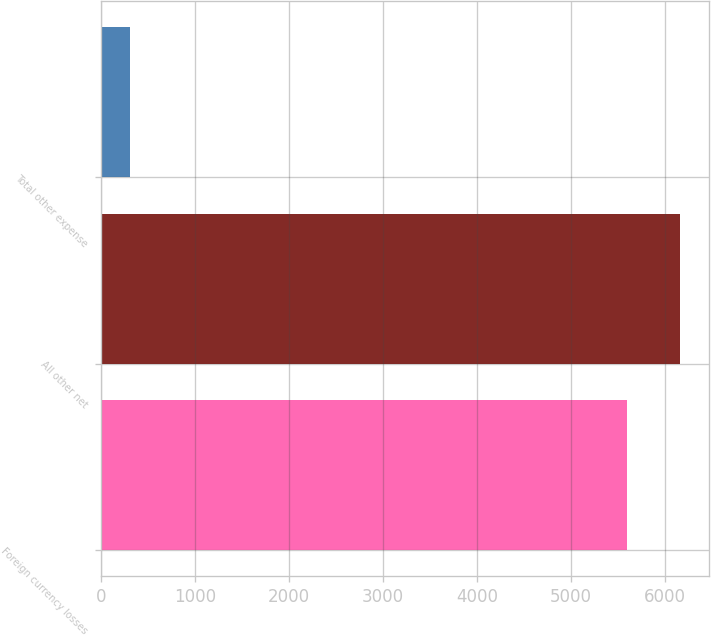<chart> <loc_0><loc_0><loc_500><loc_500><bar_chart><fcel>Foreign currency losses<fcel>All other net<fcel>Total other expense<nl><fcel>5599<fcel>6158.9<fcel>303<nl></chart> 